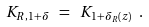Convert formula to latex. <formula><loc_0><loc_0><loc_500><loc_500>K _ { R , 1 + \delta } \ = \ K _ { 1 + \delta _ { R } ( z ) } \ .</formula> 